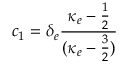Convert formula to latex. <formula><loc_0><loc_0><loc_500><loc_500>c _ { 1 } = \delta _ { e } \frac { \kappa _ { e } - \frac { 1 } { 2 } } { ( \kappa _ { e } - \frac { 3 } { 2 } ) }</formula> 